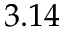<formula> <loc_0><loc_0><loc_500><loc_500>3 . 1 4</formula> 